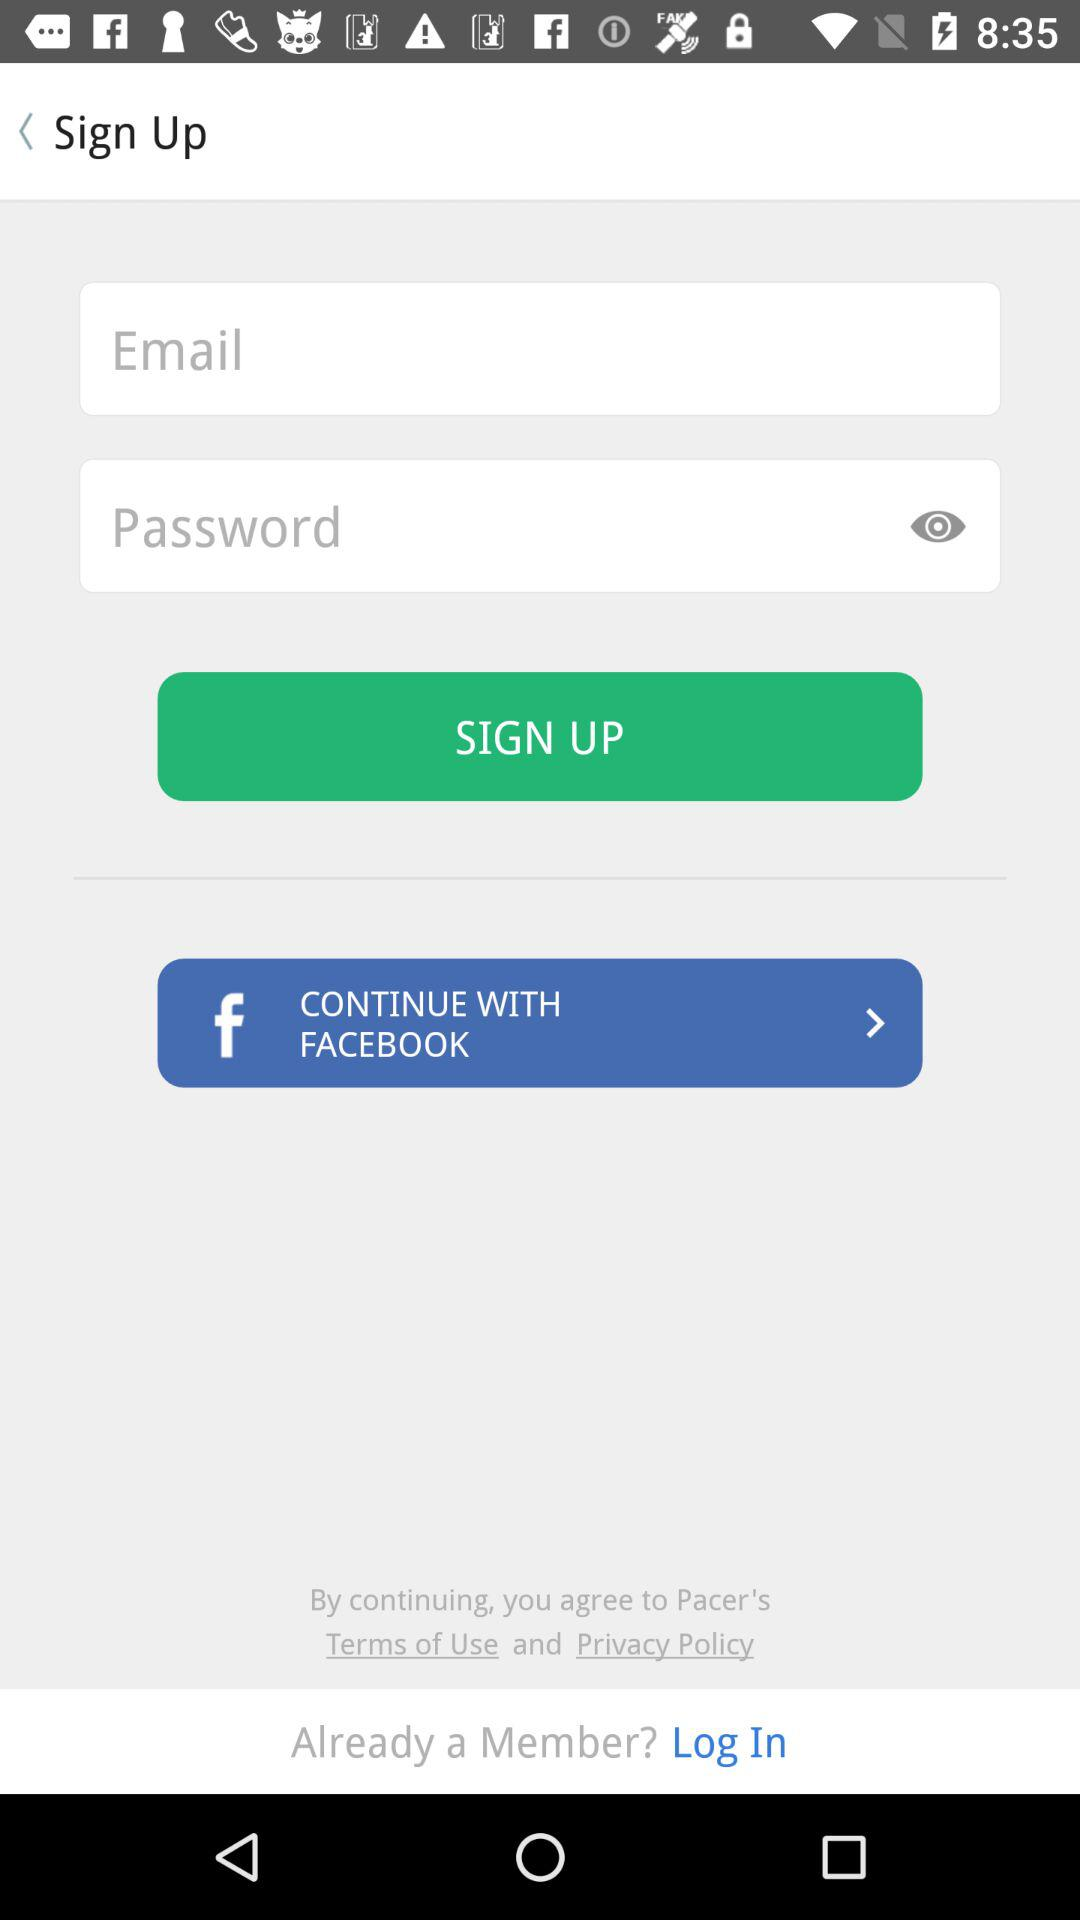What is the name of the application? The names of the applications are "FACEBOOK" and "Pacer". 